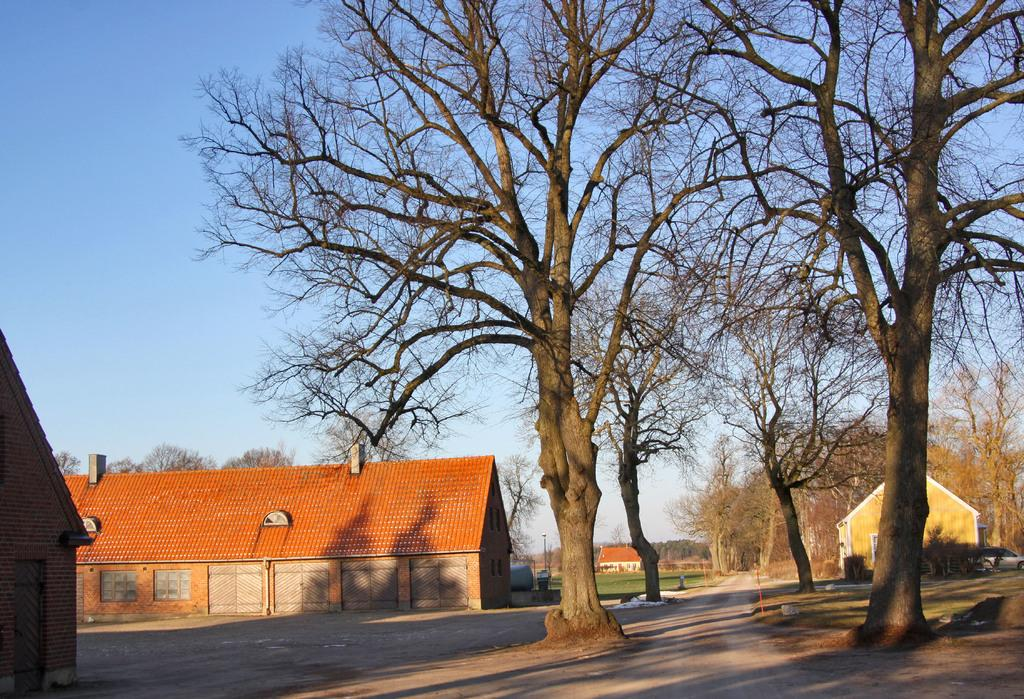What type of structures can be seen in the image? There are houses in the image. What type of vegetation is present in the image? There are trees and grass in the image. Where is the car located in the image? The car is on the right side of the image. What type of adjustment can be seen being made at the hospital in the image? There is no hospital or adjustment present in the image. What is the wealth status of the people living in the houses in the image? The wealth status of the people living in the houses cannot be determined from the image. 